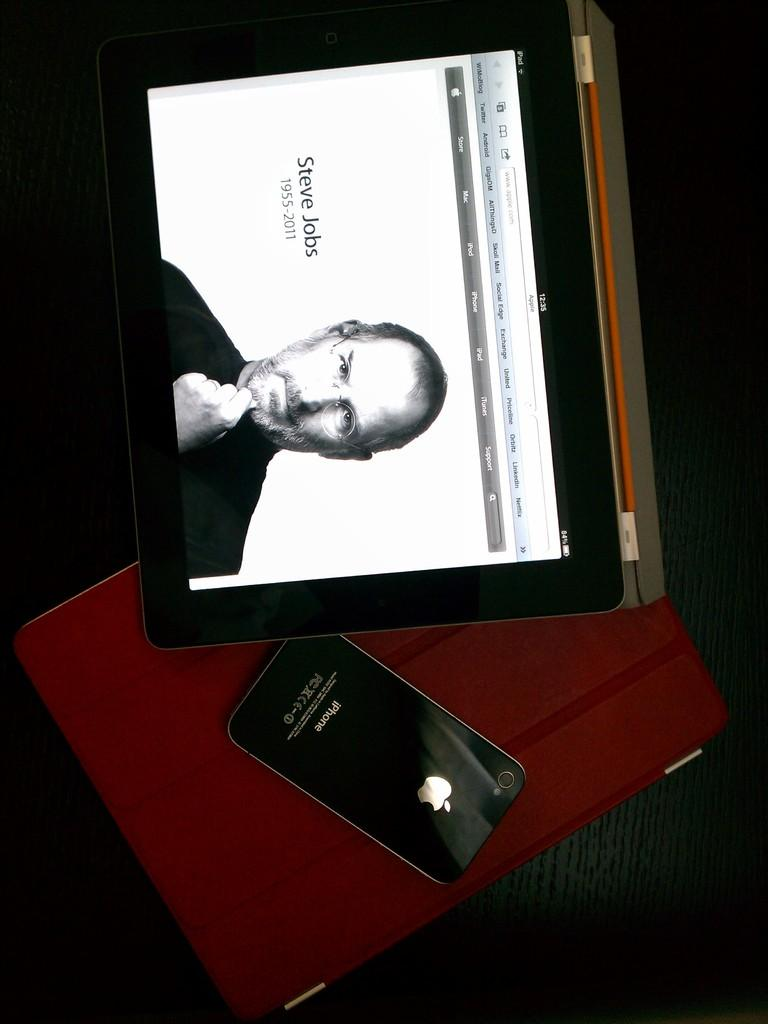<image>
Describe the image concisely. An iPhone is placed next to a picture of Steve Jobs. 